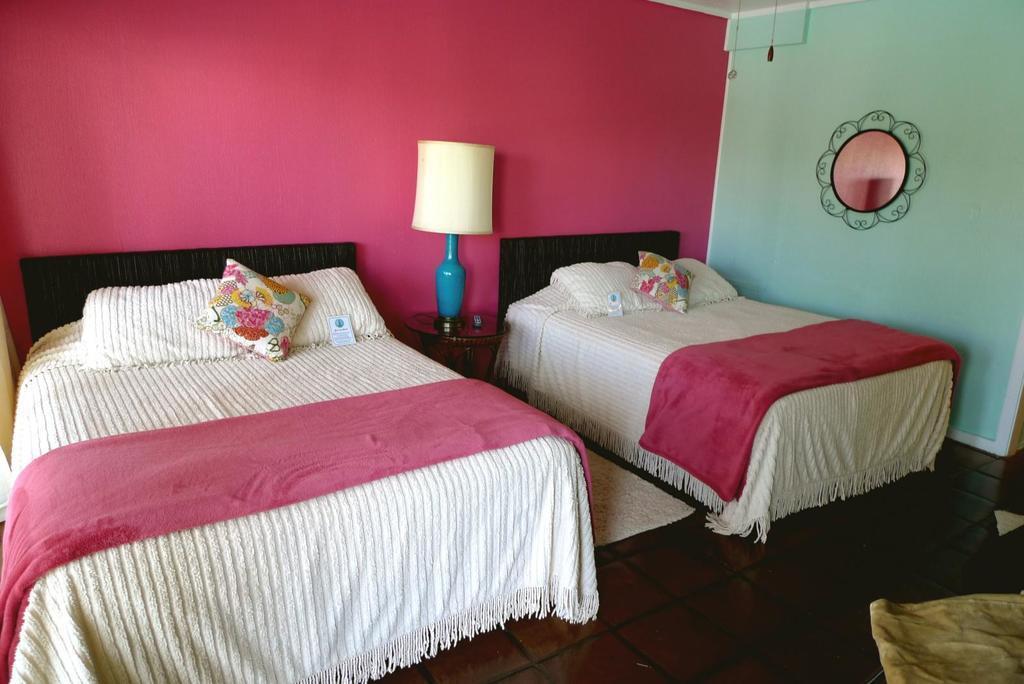In one or two sentences, can you explain what this image depicts? In the picture we can see two beds with pillows and in the middle of the beds we can see a lamp and behind the beds we can see the wall which is pink in color and beside it we can see the wall and a mirror to it. 